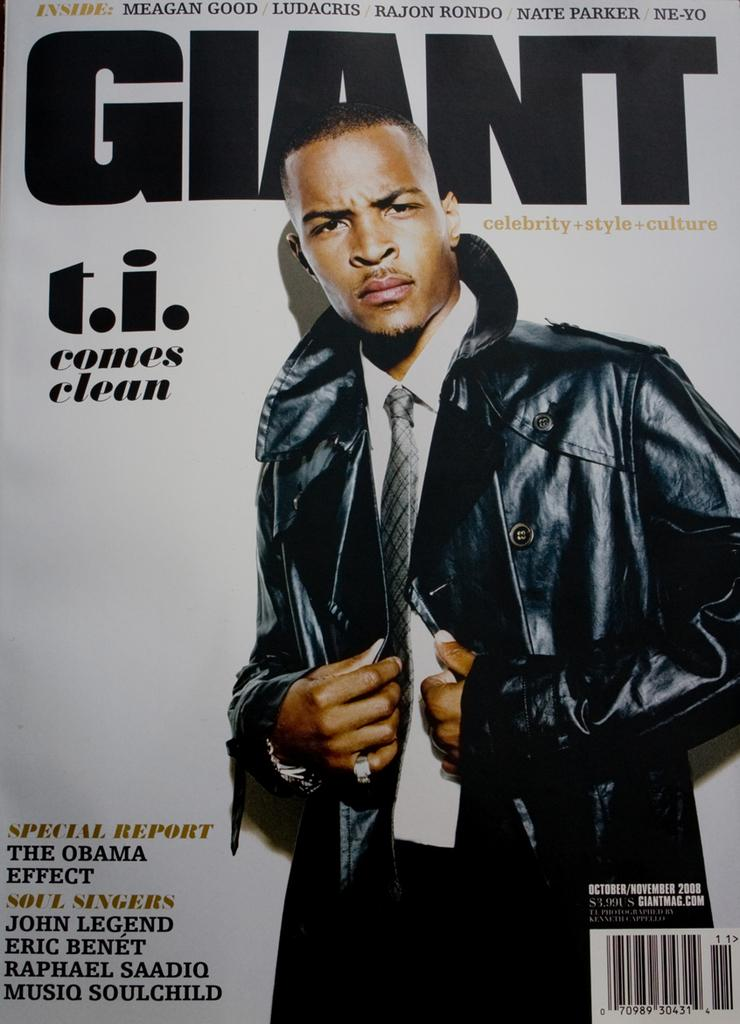What is the main subject of the magazine cover in the image? There is a picture of a person on a magazine cover. What else can be seen on the magazine cover besides the person's picture? There is text on the magazine cover. How many deer are visible on the magazine cover? There are no deer present on the magazine cover; it features a picture of a person and text. What is the name of the daughter mentioned on the magazine cover? There is no mention of a daughter on the magazine cover; it only features a picture of a person and text. 